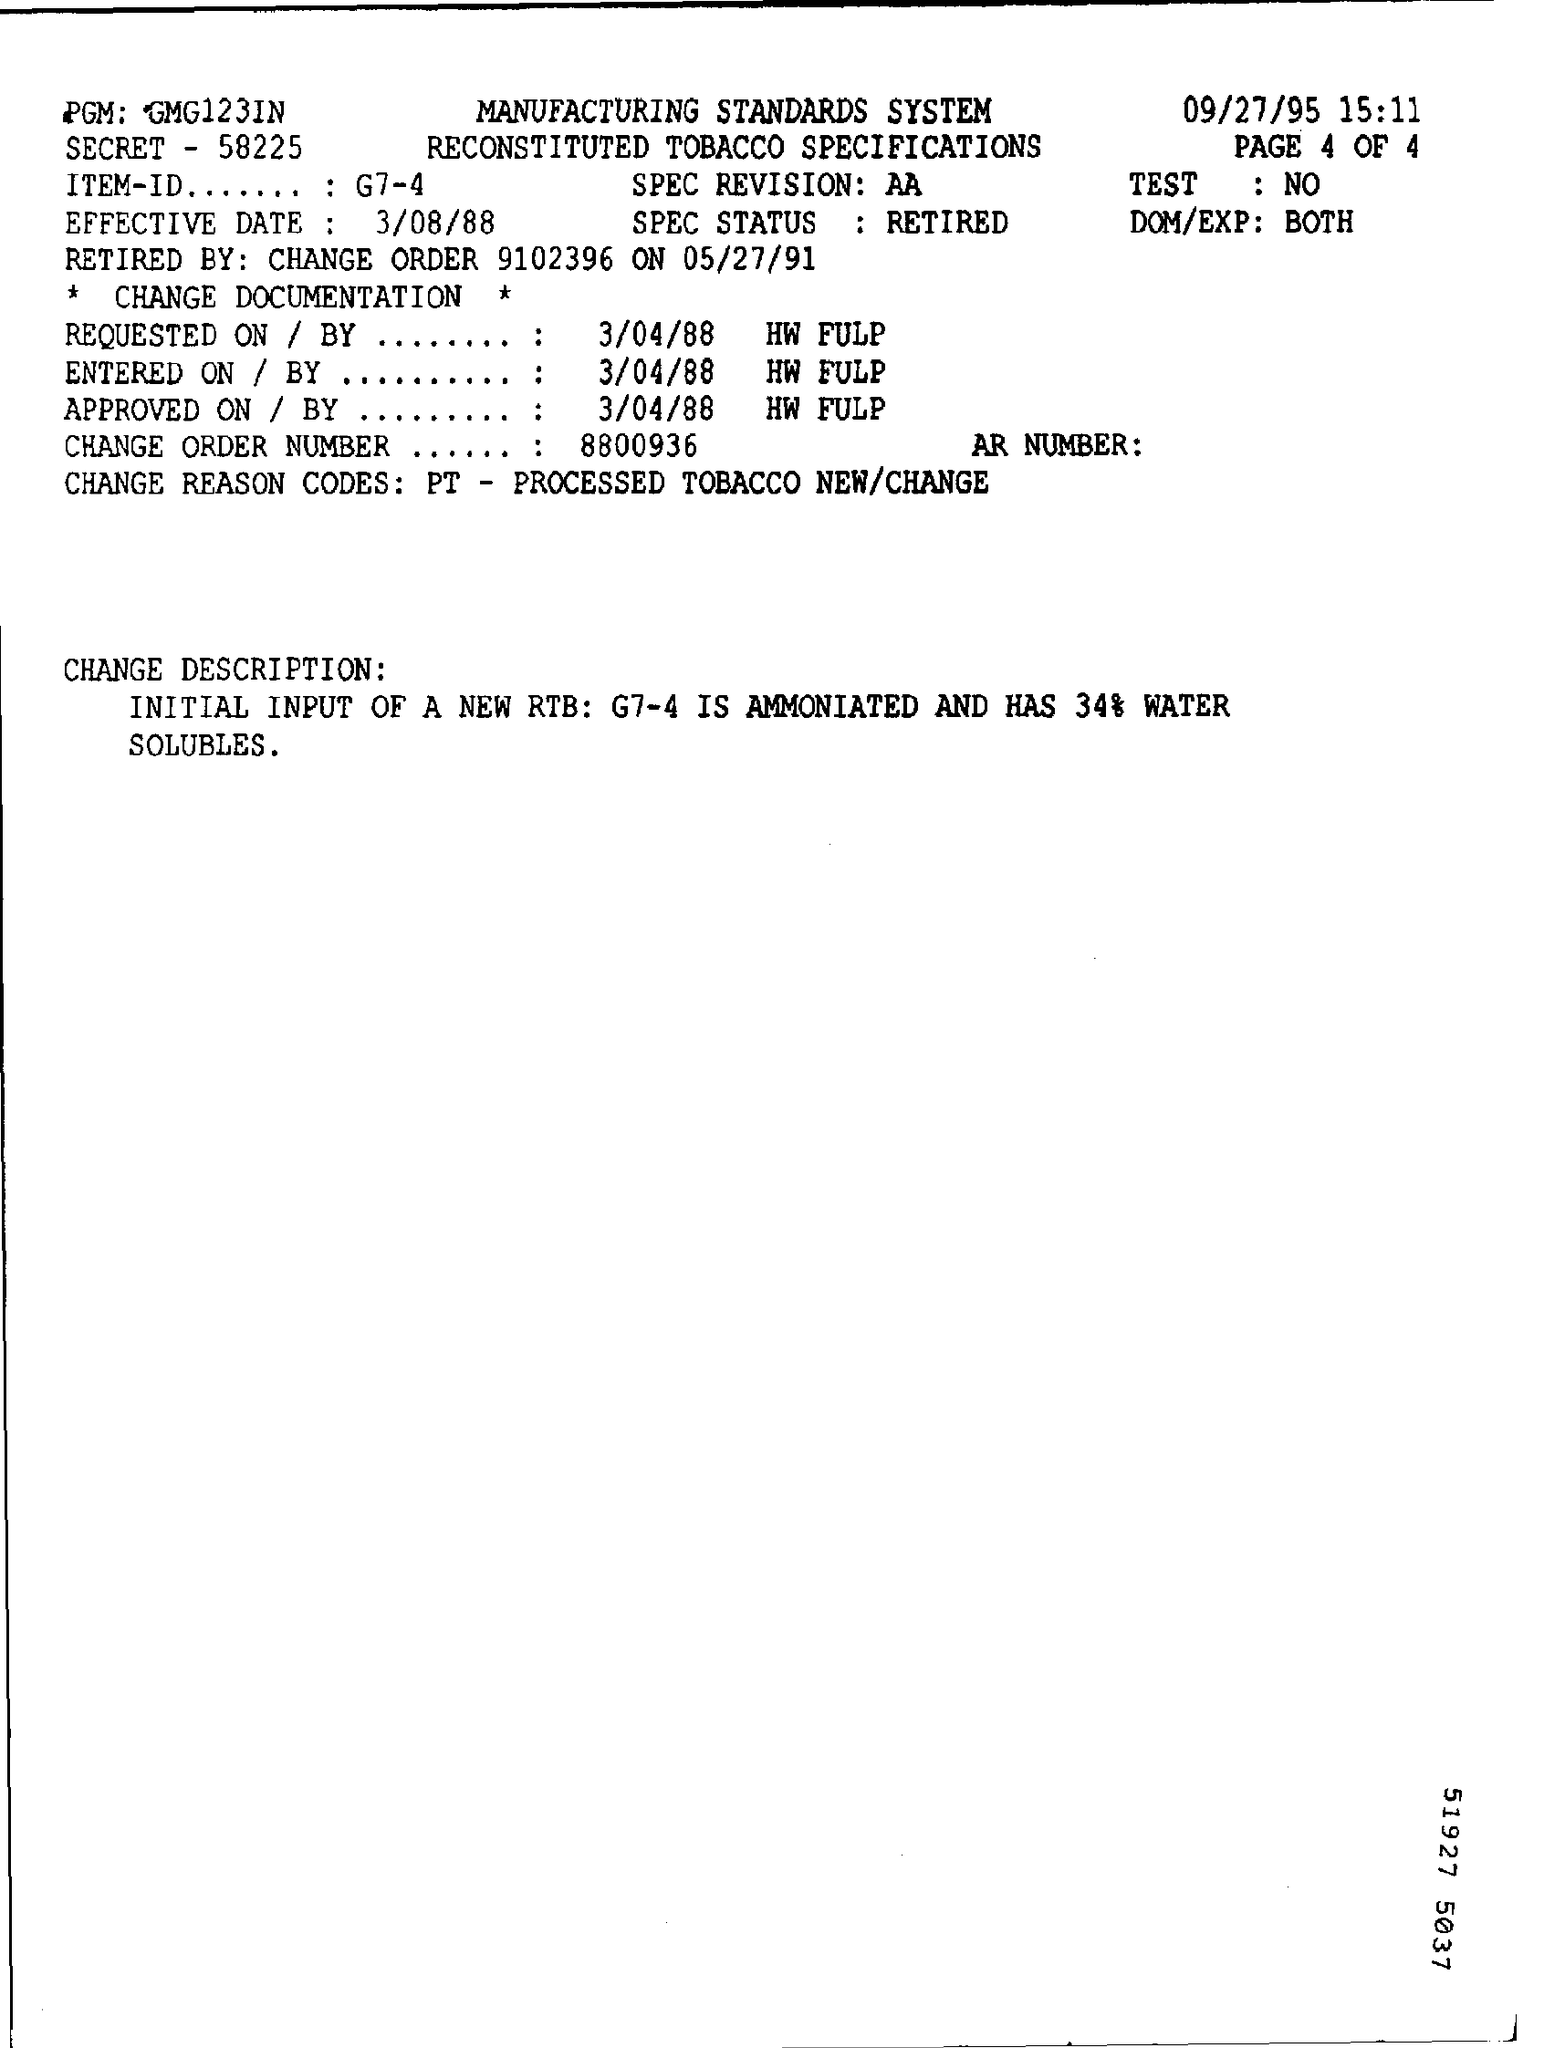What is the SPEC Status ?
Your response must be concise. Retired. What is the 'Effective Date' ?
Your response must be concise. 3/08/88. What is the change order number ?
Your response must be concise. 8800936. 